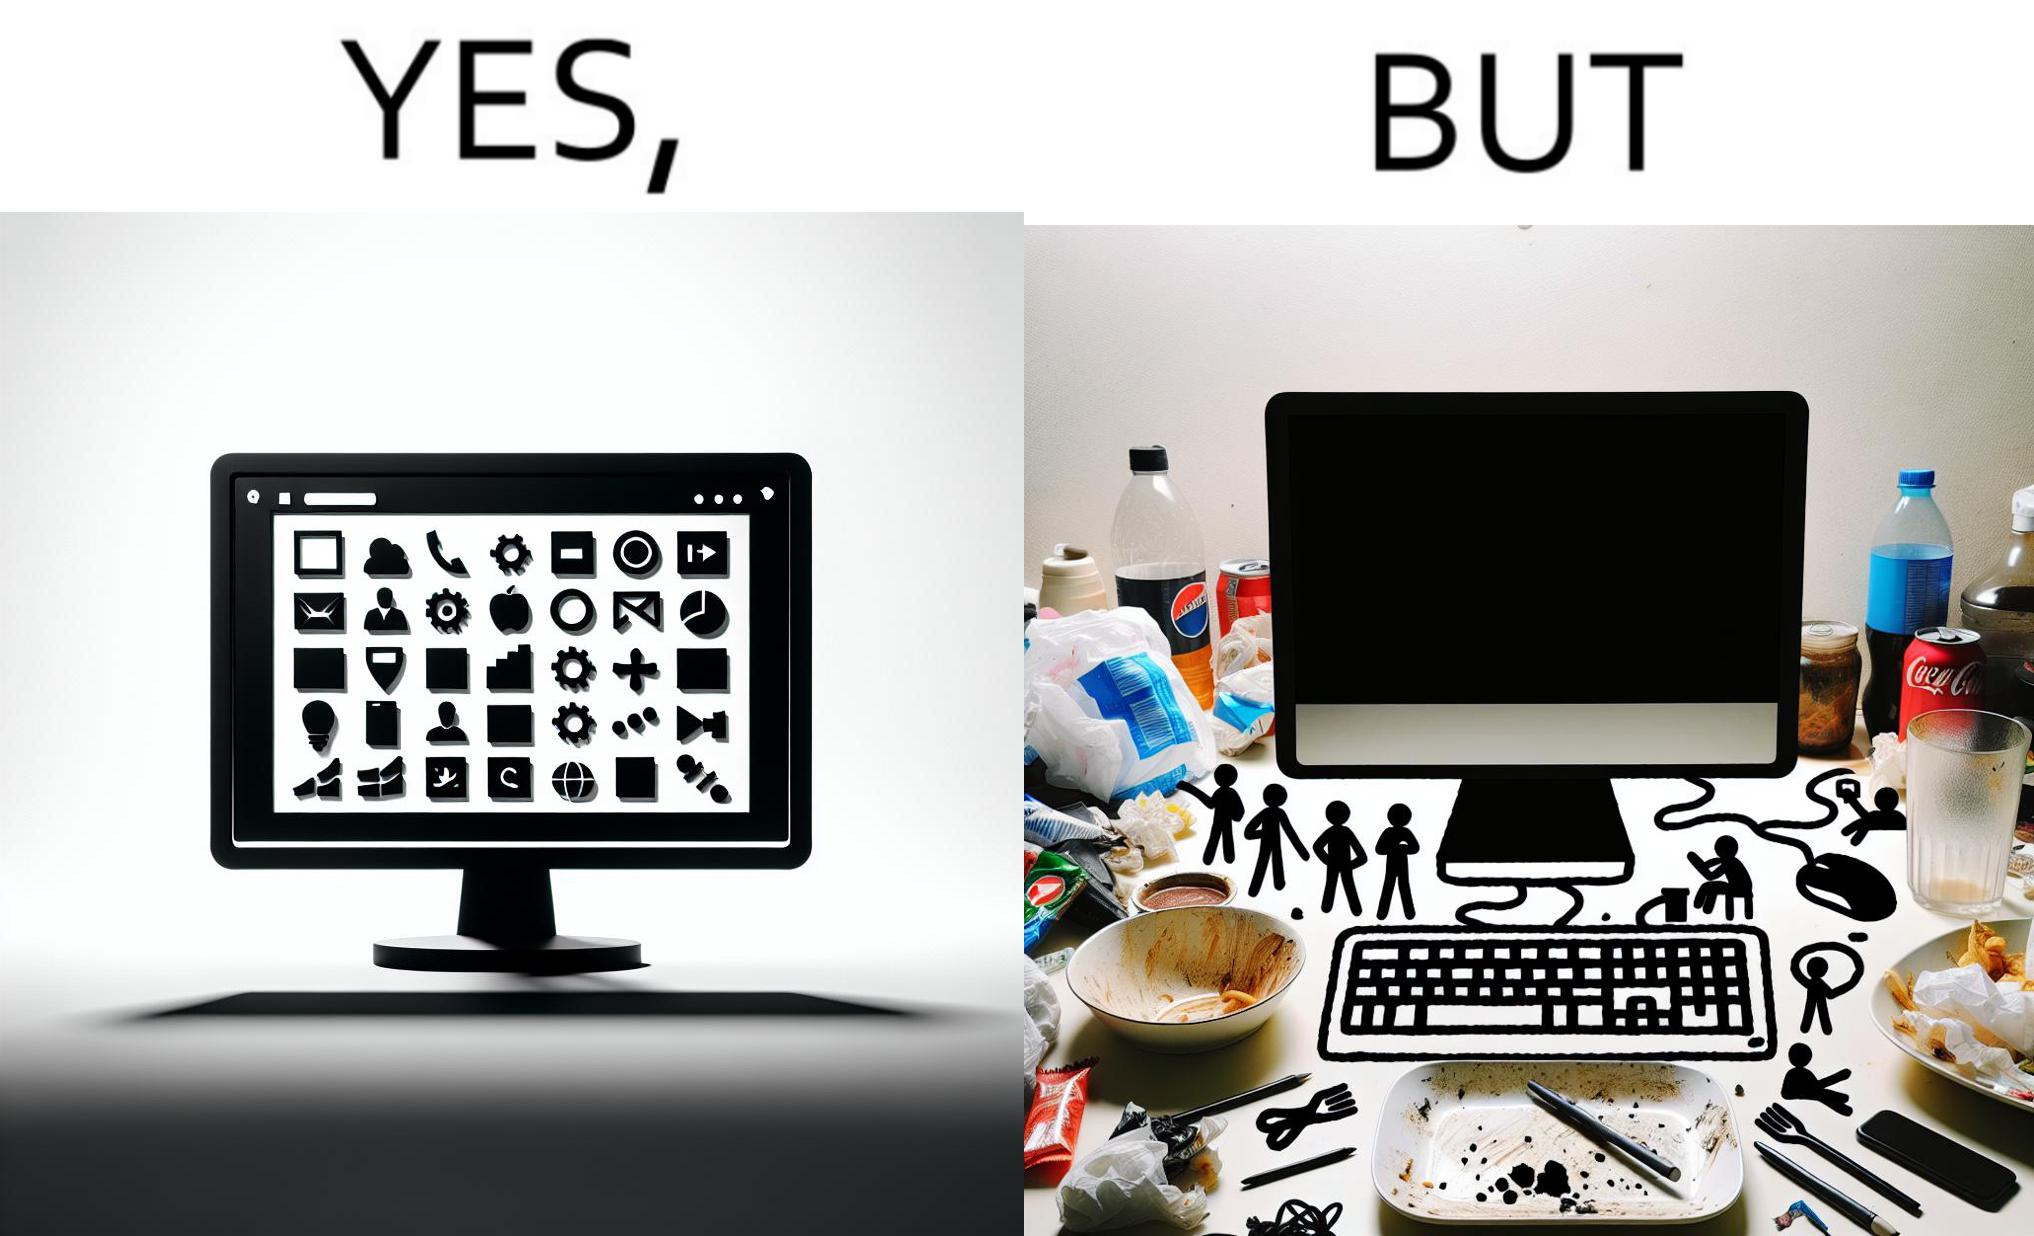Describe what you see in the left and right parts of this image. In the left part of the image: A desktop screen opened in a computer monitor. In the right part of the image: A desktop screen opened in a computer monitor on a table littered with used food packets, dirty plates, and wrappers 